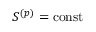Convert formula to latex. <formula><loc_0><loc_0><loc_500><loc_500>S ^ { ( p ) } = { c o n s t }</formula> 